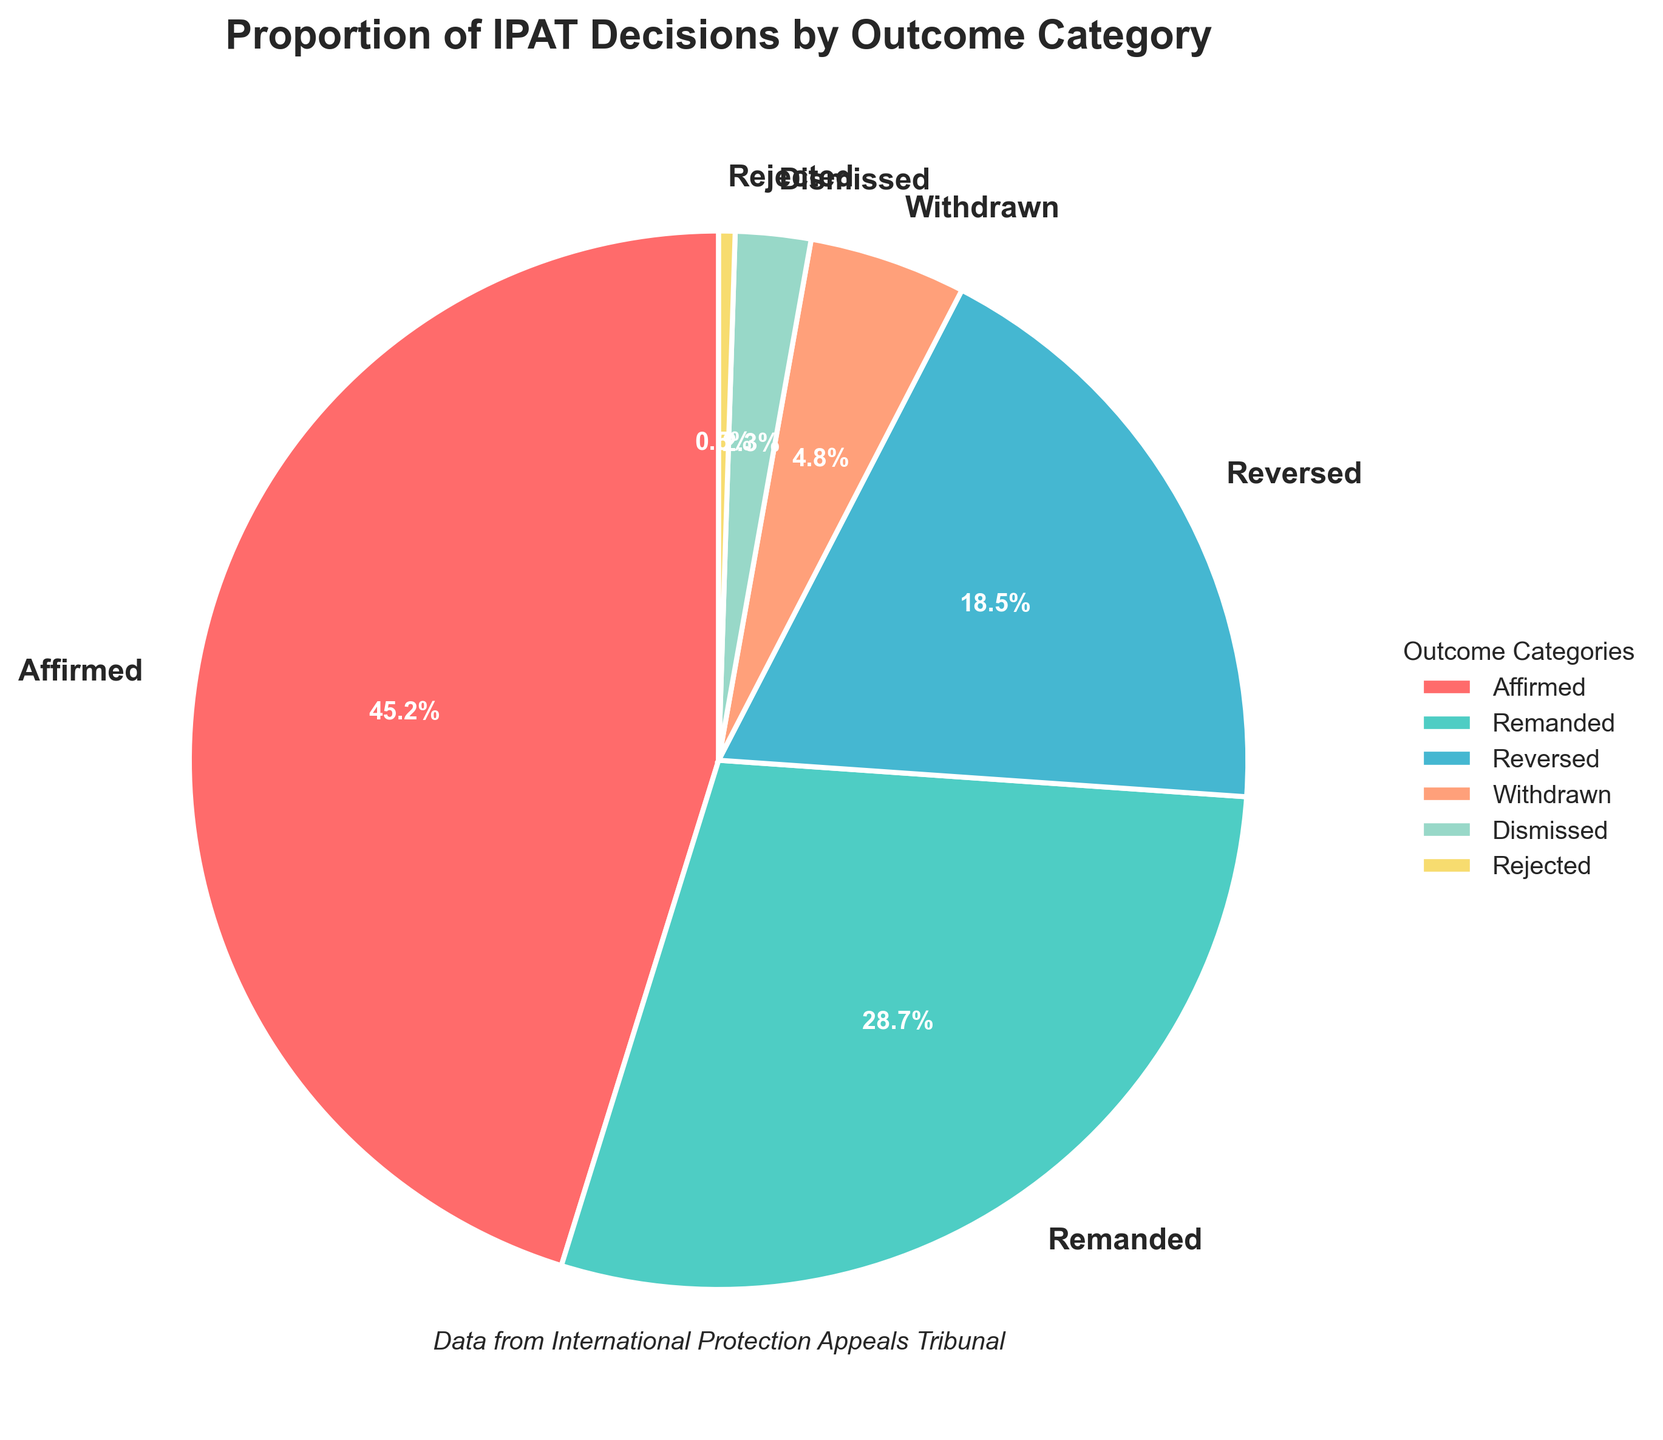What's the category with the highest proportion of IPAT decisions? The category with the highest proportion is indicated by the largest wedge in the pie chart. This wedge is labeled "Affirmed".
Answer: Affirmed Which category has a higher proportion, Reversed or Remanded? By comparing the sizes of the wedges in the pie chart, it's clear that the wedge for "Remanded" is larger than that for "Reversed".
Answer: Remanded What's the combined proportion of Dismissed and Rejected decisions? The proportions for Dismissed and Rejected decisions are 2.3% and 0.5%, respectively. Adding these gives 2.3% + 0.5% = 2.8%.
Answer: 2.8% What is the difference in proportion between Affirmed and Remanded decisions? The proportions for Affirmed and Remanded decisions are 45.2% and 28.7%, respectively. Subtracting these gives 45.2% - 28.7% = 16.5%.
Answer: 16.5% How many categories have a proportion higher than 10%? The pie chart shows that Affirmed (45.2%), Remanded (28.7%), and Reversed (18.5%) are the only categories with proportions higher than 10%. That makes it three categories.
Answer: 3 What color represents the Affirmed category? The color legend next to the pie chart associates pink with the Affirmed category.
Answer: Pink Between Withdrawn and Dismissed, which category has a smaller proportion? The proportions for Withdrawn and Dismissed are 4.8% and 2.3%, respectively. The wedge for Dismissed is smaller.
Answer: Dismissed If Affirmed and Remanded decisions are combined, what proportion would they represent? The proportions for Affirmed and Remanded are 45.2% and 28.7%, respectively. The combined proportion is 45.2% + 28.7% = 73.9%.
Answer: 73.9% What is the proportion difference between the least and the most frequent categories? The proportion for the most frequent category (Affirmed) is 45.2%, and for the least frequent category (Rejected) it is 0.5%. The difference is 45.2% - 0.5% = 44.7%.
Answer: 44.7% 